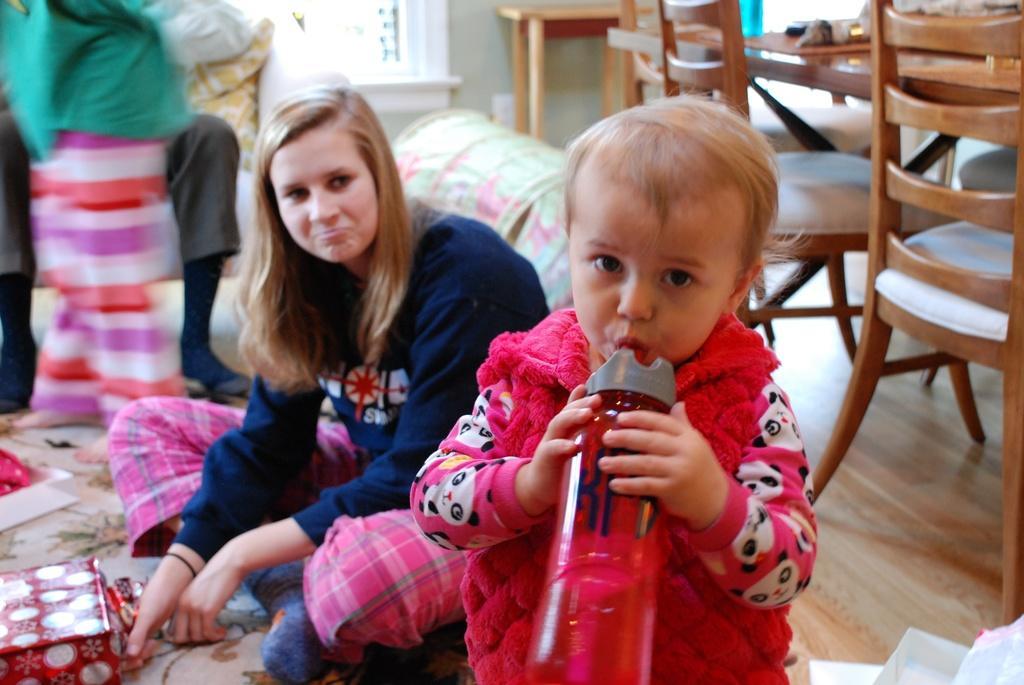Describe this image in one or two sentences. In the picture we can see a woman sitting on the floor and near to her we can see a small boy standing and holding a water bottle and he is wearing a red color hoodie and woman is wearing a blue color hoodie and behind her we can see some chairs and table and beside her we can see a person sitting and one person is standing and in the background we can see a wall with a window frame. 